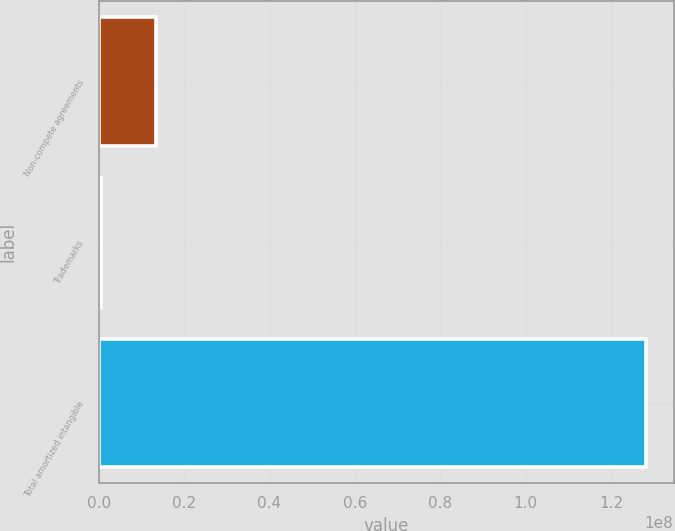<chart> <loc_0><loc_0><loc_500><loc_500><bar_chart><fcel>Non-compete agreements<fcel>Trademarks<fcel>Total amortized intangible<nl><fcel>1.32768e+07<fcel>500000<fcel>1.28268e+08<nl></chart> 